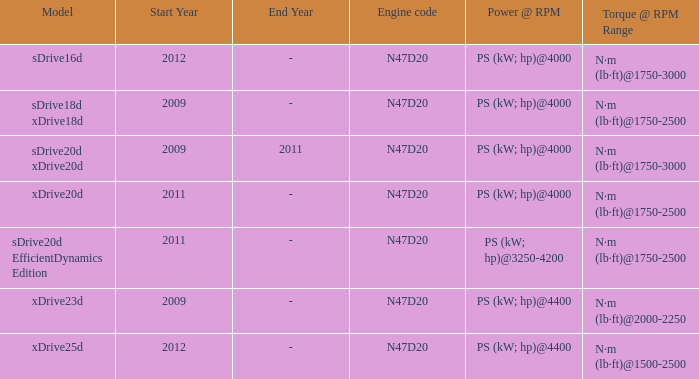What is the engine code of the xdrive23d model? N47D20. 